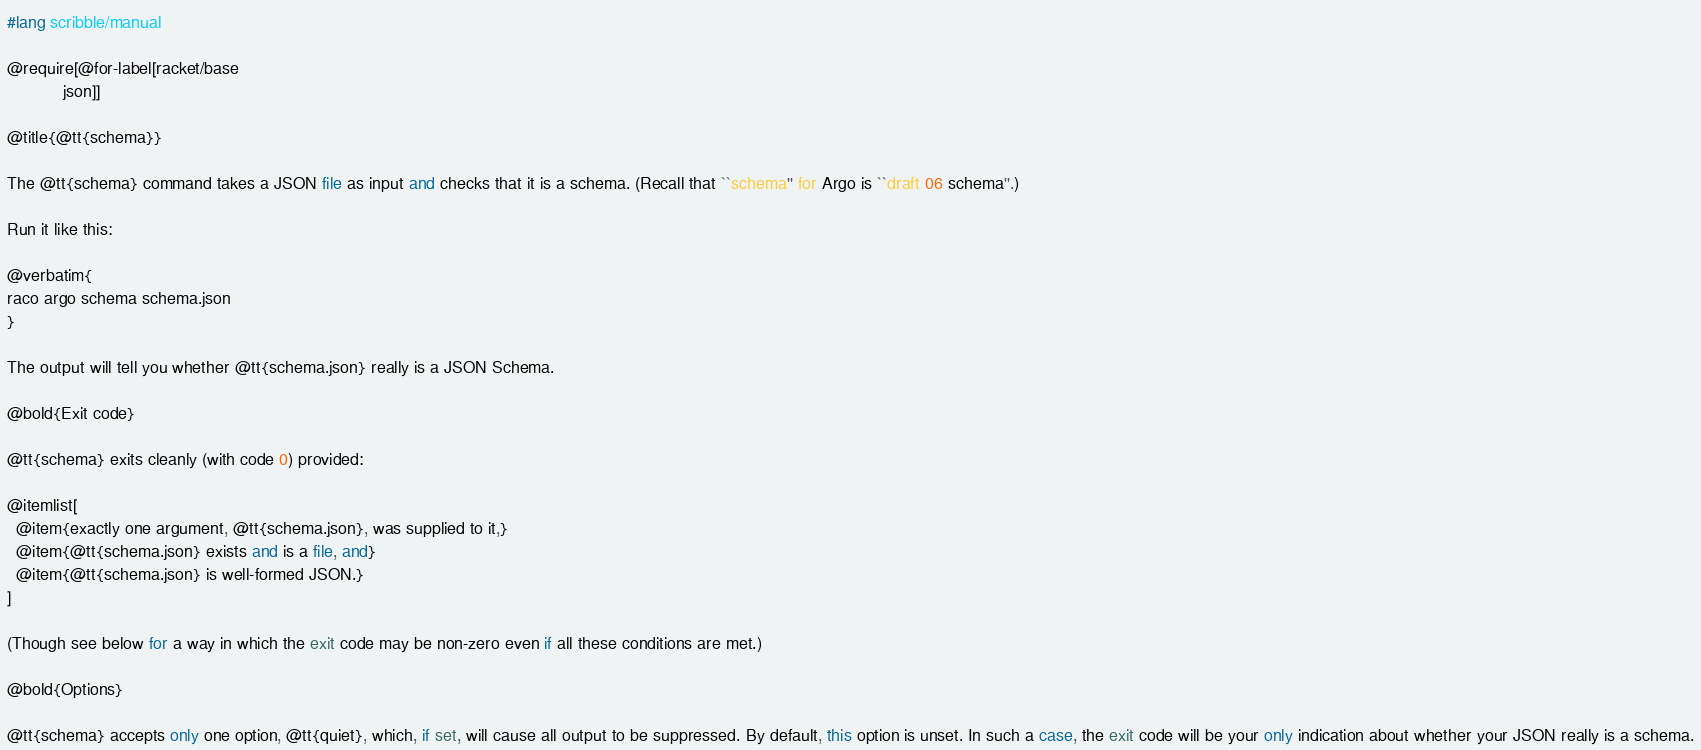<code> <loc_0><loc_0><loc_500><loc_500><_Racket_>#lang scribble/manual

@require[@for-label[racket/base
		    json]]

@title{@tt{schema}}

The @tt{schema} command takes a JSON file as input and checks that it is a schema. (Recall that ``schema'' for Argo is ``draft 06 schema''.)

Run it like this:

@verbatim{
raco argo schema schema.json
}

The output will tell you whether @tt{schema.json} really is a JSON Schema.

@bold{Exit code}

@tt{schema} exits cleanly (with code 0) provided:

@itemlist[
  @item{exactly one argument, @tt{schema.json}, was supplied to it,}
  @item{@tt{schema.json} exists and is a file, and}
  @item{@tt{schema.json} is well-formed JSON.}
]

(Though see below for a way in which the exit code may be non-zero even if all these conditions are met.)

@bold{Options}

@tt{schema} accepts only one option, @tt{quiet}, which, if set, will cause all output to be suppressed. By default, this option is unset. In such a case, the exit code will be your only indication about whether your JSON really is a schema.
</code> 